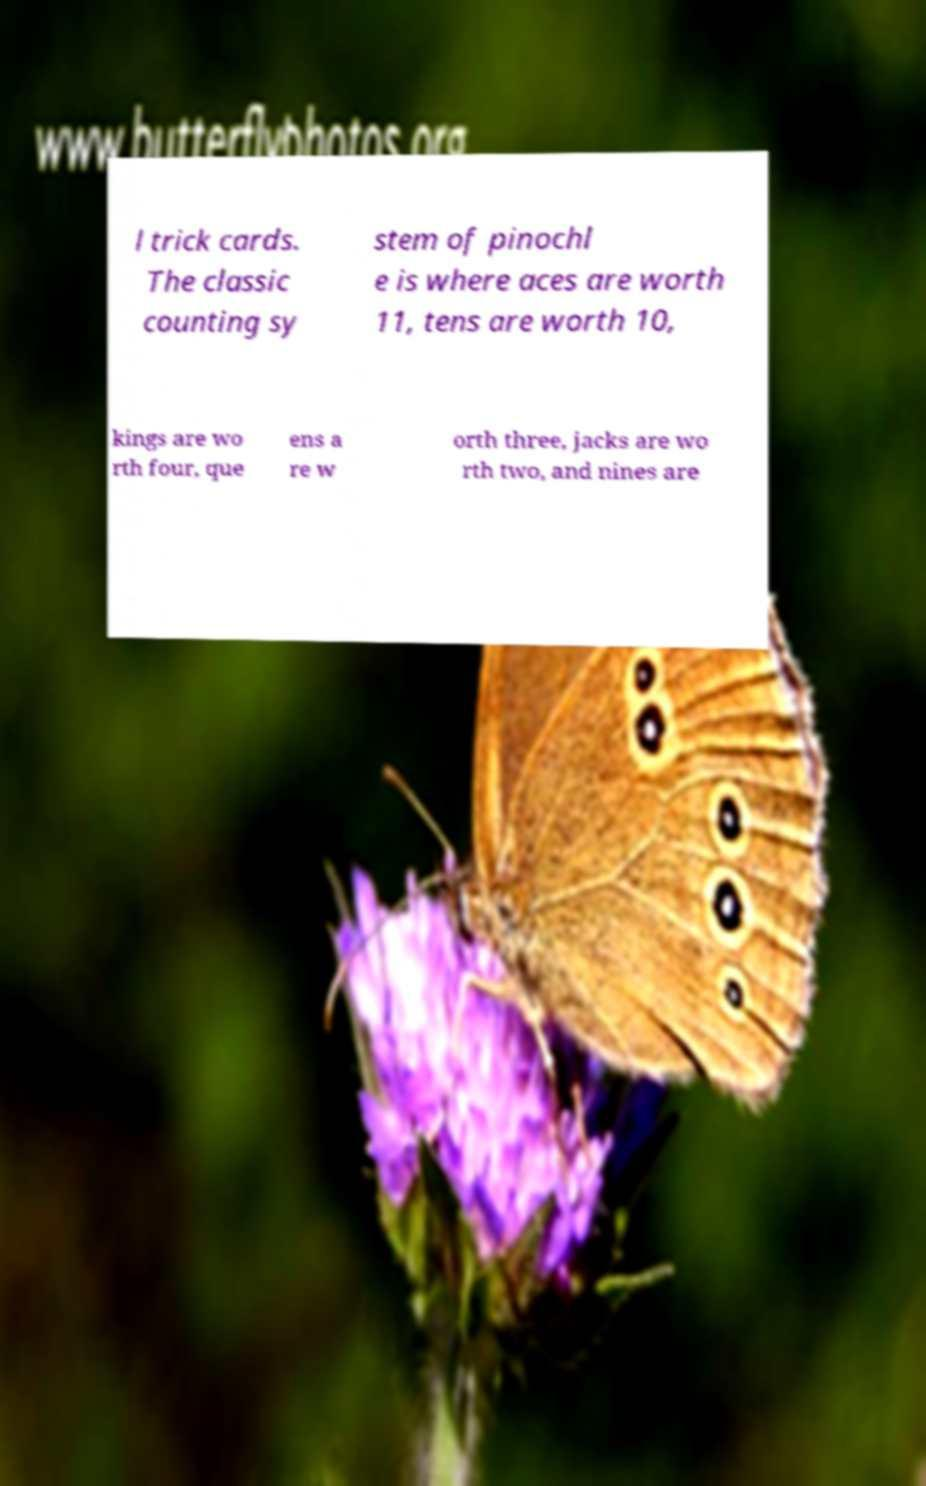What messages or text are displayed in this image? I need them in a readable, typed format. l trick cards. The classic counting sy stem of pinochl e is where aces are worth 11, tens are worth 10, kings are wo rth four, que ens a re w orth three, jacks are wo rth two, and nines are 